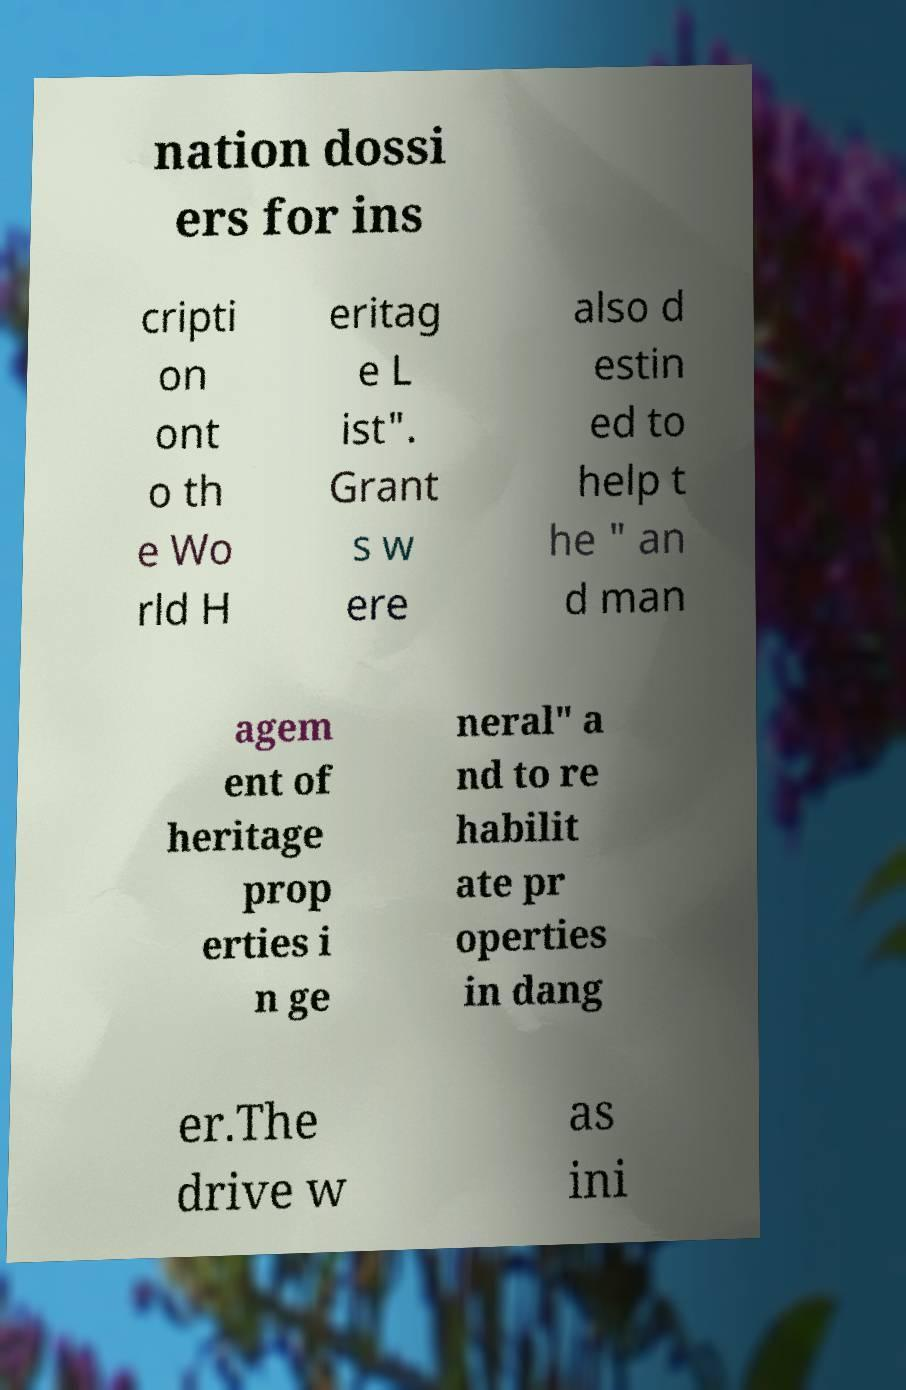What messages or text are displayed in this image? I need them in a readable, typed format. nation dossi ers for ins cripti on ont o th e Wo rld H eritag e L ist". Grant s w ere also d estin ed to help t he " an d man agem ent of heritage prop erties i n ge neral" a nd to re habilit ate pr operties in dang er.The drive w as ini 